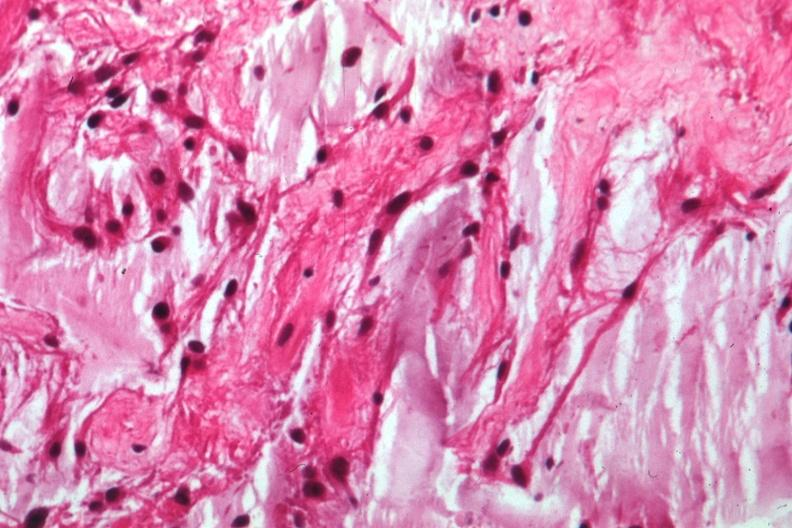what is present?
Answer the question using a single word or phrase. Eye 